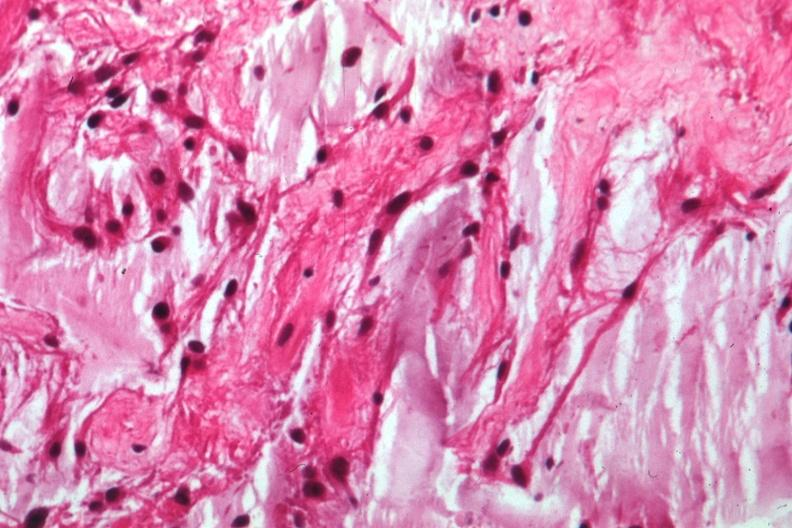what is present?
Answer the question using a single word or phrase. Eye 